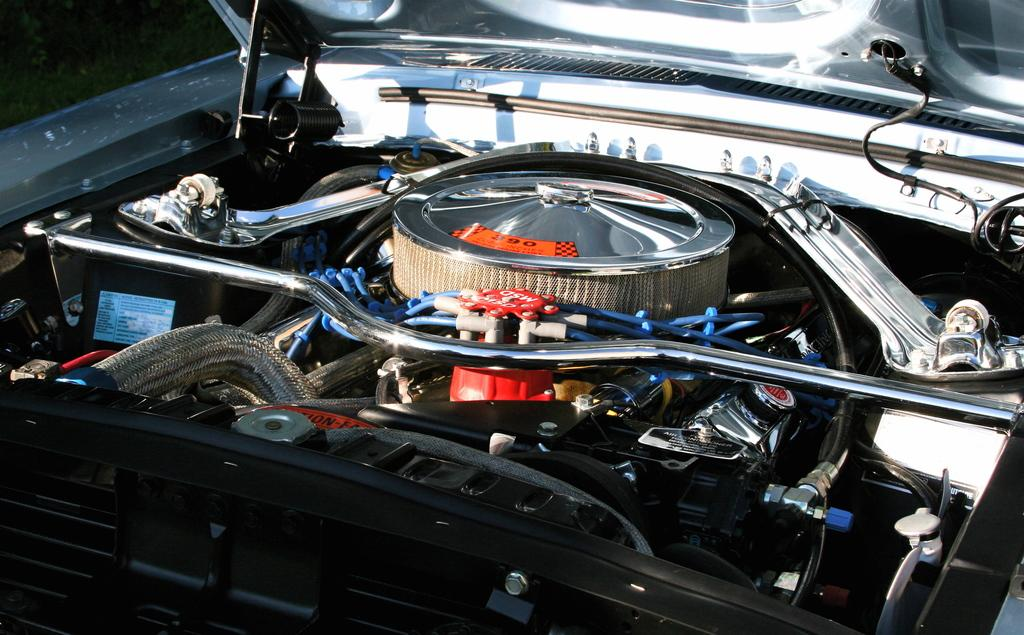What type of objects can be seen in the image? There are wires, steel rods, an engine, and other machines visible in the image. Can you describe the wires in the image? The image contains wires, but it does not provide information about their amount, measure, or grade. What type of machines are present in the image besides the engine? There are other machines in the image, but the facts provided do not specify their amount, measure, or grade. What grade of wood is used to construct the machines in the image? There is no mention of wood or its grade in the image; the machines are made of steel rods and other materials. 